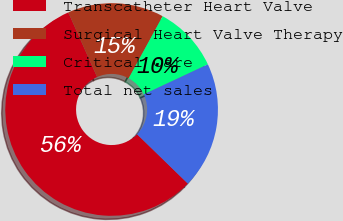Convert chart. <chart><loc_0><loc_0><loc_500><loc_500><pie_chart><fcel>Transcatheter Heart Valve<fcel>Surgical Heart Valve Therapy<fcel>Critical Care<fcel>Total net sales<nl><fcel>56.05%<fcel>14.65%<fcel>10.05%<fcel>19.25%<nl></chart> 